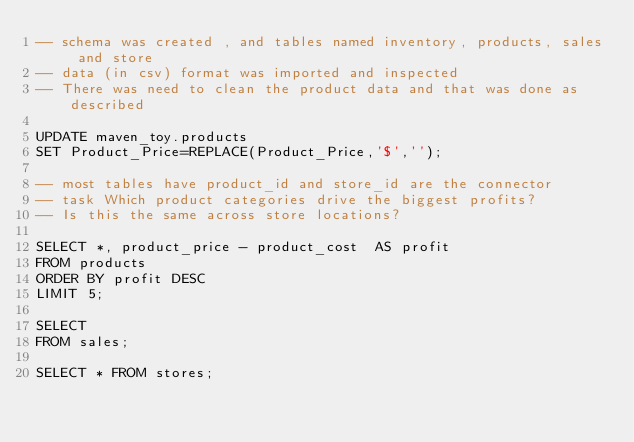Convert code to text. <code><loc_0><loc_0><loc_500><loc_500><_SQL_>-- schema was created , and tables named inventory, products, sales and store
-- data (in csv) format was imported and inspected
-- There was need to clean the product data and that was done as described 

UPDATE maven_toy.products
SET Product_Price=REPLACE(Product_Price,'$','');

-- most tables have product_id and store_id are the connector
-- task Which product categories drive the biggest profits? 
-- Is this the same across store locations?

SELECT *, product_price - product_cost  AS profit
FROM products
ORDER BY profit DESC
LIMIT 5;

SELECT 
FROM sales;

SELECT * FROM stores;</code> 